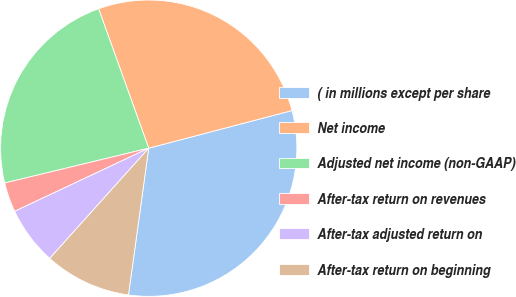Convert chart to OTSL. <chart><loc_0><loc_0><loc_500><loc_500><pie_chart><fcel>( in millions except per share<fcel>Net income<fcel>Adjusted net income (non-GAAP)<fcel>After-tax return on revenues<fcel>After-tax adjusted return on<fcel>After-tax return on beginning<nl><fcel>31.27%<fcel>26.4%<fcel>23.28%<fcel>3.23%<fcel>6.35%<fcel>9.46%<nl></chart> 